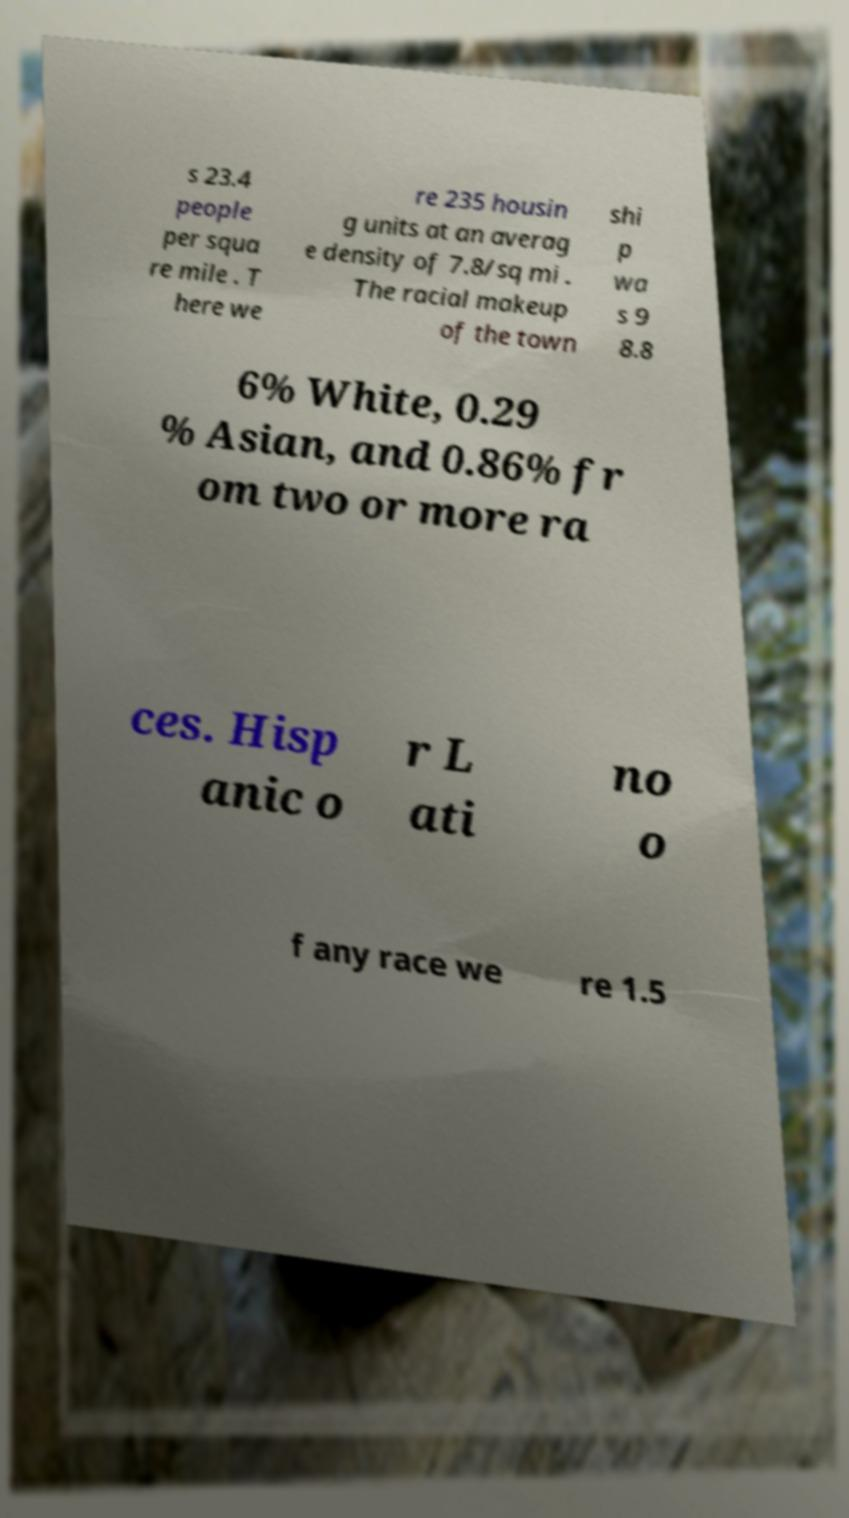For documentation purposes, I need the text within this image transcribed. Could you provide that? s 23.4 people per squa re mile . T here we re 235 housin g units at an averag e density of 7.8/sq mi . The racial makeup of the town shi p wa s 9 8.8 6% White, 0.29 % Asian, and 0.86% fr om two or more ra ces. Hisp anic o r L ati no o f any race we re 1.5 